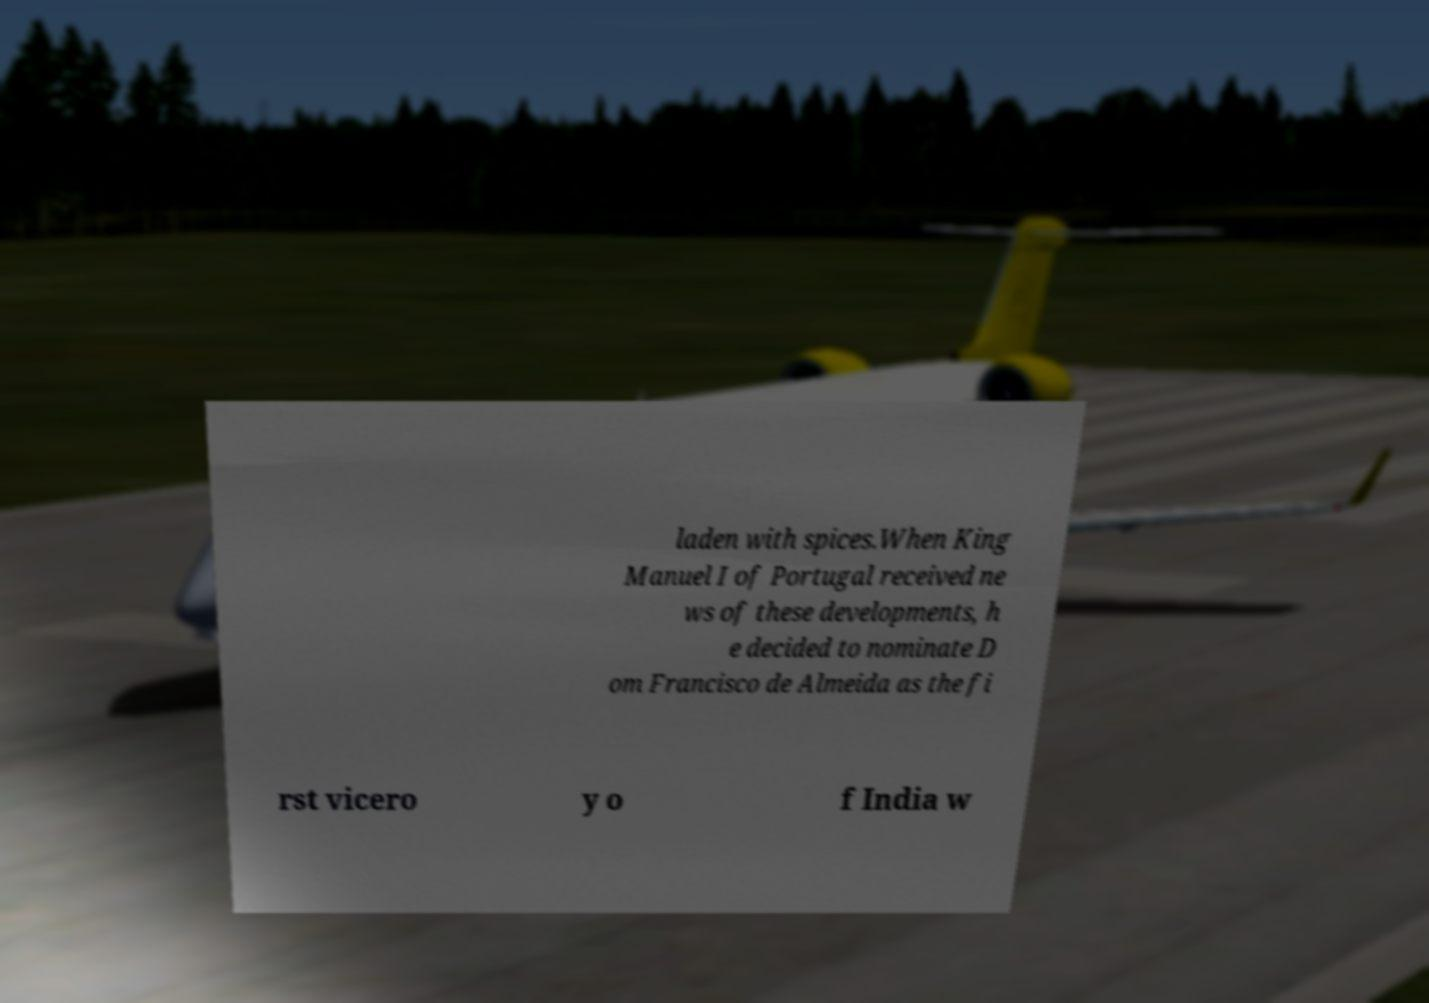Could you extract and type out the text from this image? laden with spices.When King Manuel I of Portugal received ne ws of these developments, h e decided to nominate D om Francisco de Almeida as the fi rst vicero y o f India w 